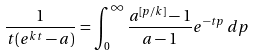Convert formula to latex. <formula><loc_0><loc_0><loc_500><loc_500>\frac { 1 } { t ( e ^ { k t } - a ) } = \int _ { 0 } ^ { \infty } \frac { a ^ { [ p / k ] } - 1 } { a - 1 } e ^ { - t p } \, d p</formula> 